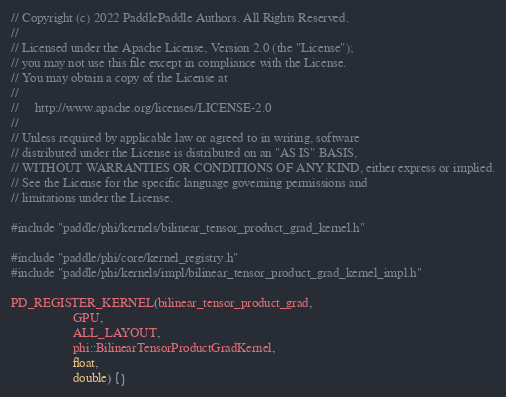Convert code to text. <code><loc_0><loc_0><loc_500><loc_500><_Cuda_>// Copyright (c) 2022 PaddlePaddle Authors. All Rights Reserved.
//
// Licensed under the Apache License, Version 2.0 (the "License");
// you may not use this file except in compliance with the License.
// You may obtain a copy of the License at
//
//     http://www.apache.org/licenses/LICENSE-2.0
//
// Unless required by applicable law or agreed to in writing, software
// distributed under the License is distributed on an "AS IS" BASIS,
// WITHOUT WARRANTIES OR CONDITIONS OF ANY KIND, either express or implied.
// See the License for the specific language governing permissions and
// limitations under the License.

#include "paddle/phi/kernels/bilinear_tensor_product_grad_kernel.h"

#include "paddle/phi/core/kernel_registry.h"
#include "paddle/phi/kernels/impl/bilinear_tensor_product_grad_kernel_impl.h"

PD_REGISTER_KERNEL(bilinear_tensor_product_grad,
                   GPU,
                   ALL_LAYOUT,
                   phi::BilinearTensorProductGradKernel,
                   float,
                   double) {}
</code> 